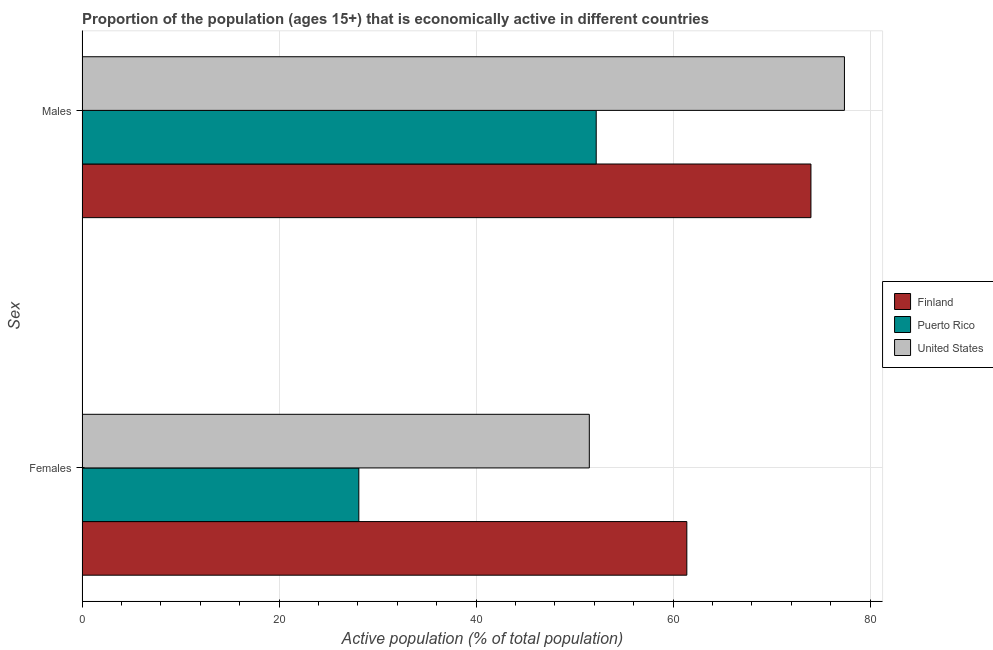Are the number of bars per tick equal to the number of legend labels?
Make the answer very short. Yes. How many bars are there on the 1st tick from the bottom?
Your answer should be compact. 3. What is the label of the 2nd group of bars from the top?
Make the answer very short. Females. What is the percentage of economically active female population in United States?
Keep it short and to the point. 51.5. Across all countries, what is the maximum percentage of economically active female population?
Give a very brief answer. 61.4. Across all countries, what is the minimum percentage of economically active male population?
Give a very brief answer. 52.2. In which country was the percentage of economically active male population minimum?
Provide a succinct answer. Puerto Rico. What is the total percentage of economically active female population in the graph?
Give a very brief answer. 141. What is the difference between the percentage of economically active male population in United States and that in Puerto Rico?
Make the answer very short. 25.2. What is the difference between the percentage of economically active male population in Finland and the percentage of economically active female population in United States?
Give a very brief answer. 22.5. What is the average percentage of economically active female population per country?
Offer a terse response. 47. What is the difference between the percentage of economically active male population and percentage of economically active female population in Finland?
Offer a terse response. 12.6. In how many countries, is the percentage of economically active male population greater than 68 %?
Provide a succinct answer. 2. What is the ratio of the percentage of economically active male population in United States to that in Puerto Rico?
Keep it short and to the point. 1.48. In how many countries, is the percentage of economically active female population greater than the average percentage of economically active female population taken over all countries?
Offer a terse response. 2. What does the 1st bar from the bottom in Males represents?
Make the answer very short. Finland. How many bars are there?
Your answer should be compact. 6. Are all the bars in the graph horizontal?
Your answer should be compact. Yes. How many countries are there in the graph?
Your answer should be very brief. 3. What is the difference between two consecutive major ticks on the X-axis?
Your response must be concise. 20. Does the graph contain any zero values?
Provide a short and direct response. No. Does the graph contain grids?
Your answer should be very brief. Yes. How are the legend labels stacked?
Give a very brief answer. Vertical. What is the title of the graph?
Provide a short and direct response. Proportion of the population (ages 15+) that is economically active in different countries. What is the label or title of the X-axis?
Offer a very short reply. Active population (% of total population). What is the label or title of the Y-axis?
Offer a very short reply. Sex. What is the Active population (% of total population) in Finland in Females?
Your answer should be very brief. 61.4. What is the Active population (% of total population) of Puerto Rico in Females?
Offer a very short reply. 28.1. What is the Active population (% of total population) in United States in Females?
Keep it short and to the point. 51.5. What is the Active population (% of total population) of Puerto Rico in Males?
Ensure brevity in your answer.  52.2. What is the Active population (% of total population) of United States in Males?
Offer a very short reply. 77.4. Across all Sex, what is the maximum Active population (% of total population) of Finland?
Keep it short and to the point. 74. Across all Sex, what is the maximum Active population (% of total population) of Puerto Rico?
Provide a succinct answer. 52.2. Across all Sex, what is the maximum Active population (% of total population) in United States?
Your answer should be compact. 77.4. Across all Sex, what is the minimum Active population (% of total population) of Finland?
Give a very brief answer. 61.4. Across all Sex, what is the minimum Active population (% of total population) in Puerto Rico?
Your response must be concise. 28.1. Across all Sex, what is the minimum Active population (% of total population) in United States?
Offer a terse response. 51.5. What is the total Active population (% of total population) of Finland in the graph?
Your answer should be compact. 135.4. What is the total Active population (% of total population) of Puerto Rico in the graph?
Keep it short and to the point. 80.3. What is the total Active population (% of total population) in United States in the graph?
Provide a short and direct response. 128.9. What is the difference between the Active population (% of total population) in Finland in Females and that in Males?
Your response must be concise. -12.6. What is the difference between the Active population (% of total population) in Puerto Rico in Females and that in Males?
Give a very brief answer. -24.1. What is the difference between the Active population (% of total population) in United States in Females and that in Males?
Keep it short and to the point. -25.9. What is the difference between the Active population (% of total population) in Finland in Females and the Active population (% of total population) in Puerto Rico in Males?
Your response must be concise. 9.2. What is the difference between the Active population (% of total population) of Finland in Females and the Active population (% of total population) of United States in Males?
Make the answer very short. -16. What is the difference between the Active population (% of total population) in Puerto Rico in Females and the Active population (% of total population) in United States in Males?
Keep it short and to the point. -49.3. What is the average Active population (% of total population) in Finland per Sex?
Provide a succinct answer. 67.7. What is the average Active population (% of total population) of Puerto Rico per Sex?
Offer a terse response. 40.15. What is the average Active population (% of total population) of United States per Sex?
Offer a terse response. 64.45. What is the difference between the Active population (% of total population) in Finland and Active population (% of total population) in Puerto Rico in Females?
Keep it short and to the point. 33.3. What is the difference between the Active population (% of total population) of Puerto Rico and Active population (% of total population) of United States in Females?
Give a very brief answer. -23.4. What is the difference between the Active population (% of total population) of Finland and Active population (% of total population) of Puerto Rico in Males?
Offer a terse response. 21.8. What is the difference between the Active population (% of total population) in Puerto Rico and Active population (% of total population) in United States in Males?
Provide a succinct answer. -25.2. What is the ratio of the Active population (% of total population) in Finland in Females to that in Males?
Provide a short and direct response. 0.83. What is the ratio of the Active population (% of total population) of Puerto Rico in Females to that in Males?
Your answer should be compact. 0.54. What is the ratio of the Active population (% of total population) of United States in Females to that in Males?
Your response must be concise. 0.67. What is the difference between the highest and the second highest Active population (% of total population) in Puerto Rico?
Your answer should be very brief. 24.1. What is the difference between the highest and the second highest Active population (% of total population) in United States?
Your answer should be very brief. 25.9. What is the difference between the highest and the lowest Active population (% of total population) of Puerto Rico?
Keep it short and to the point. 24.1. What is the difference between the highest and the lowest Active population (% of total population) of United States?
Your answer should be very brief. 25.9. 